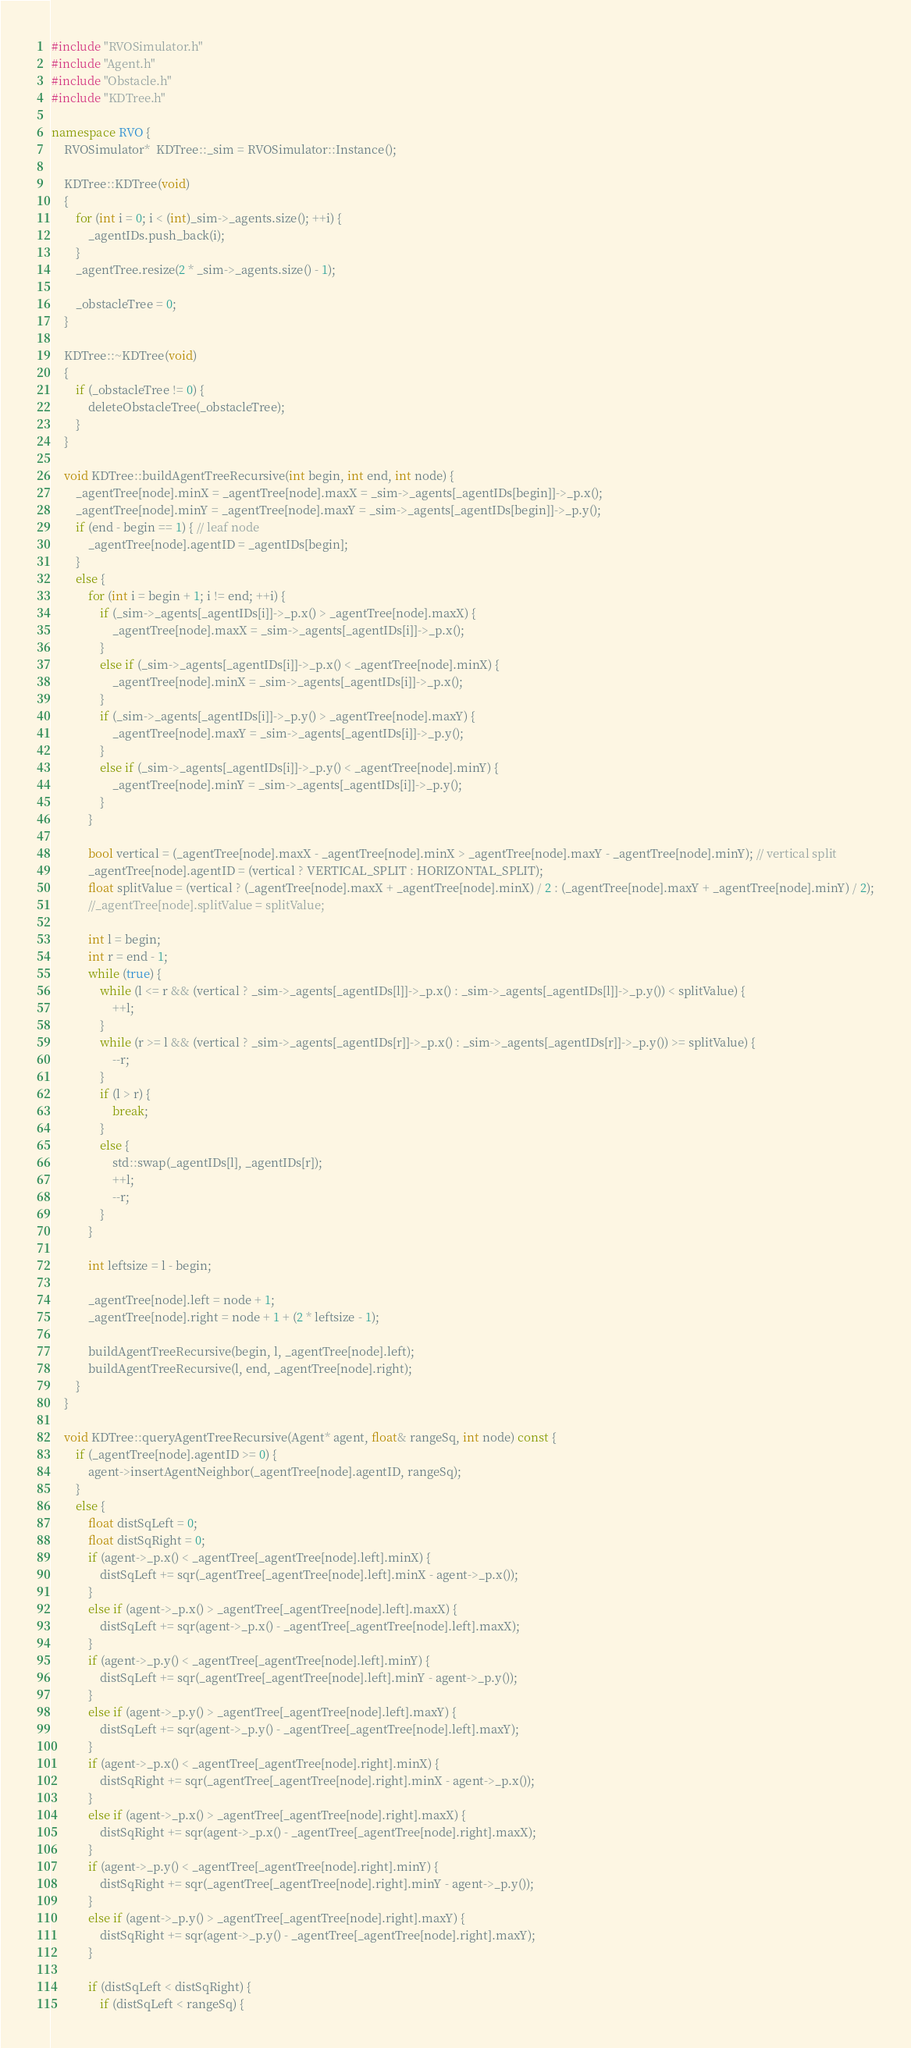Convert code to text. <code><loc_0><loc_0><loc_500><loc_500><_C++_>#include "RVOSimulator.h"
#include "Agent.h"
#include "Obstacle.h"
#include "KDTree.h"

namespace RVO {
	RVOSimulator*  KDTree::_sim = RVOSimulator::Instance();

	KDTree::KDTree(void)
	{
		for (int i = 0; i < (int)_sim->_agents.size(); ++i) {
			_agentIDs.push_back(i);
		}
		_agentTree.resize(2 * _sim->_agents.size() - 1);

		_obstacleTree = 0;
	}

	KDTree::~KDTree(void)
	{
		if (_obstacleTree != 0) {
			deleteObstacleTree(_obstacleTree);
		}
	}

	void KDTree::buildAgentTreeRecursive(int begin, int end, int node) {
		_agentTree[node].minX = _agentTree[node].maxX = _sim->_agents[_agentIDs[begin]]->_p.x();
		_agentTree[node].minY = _agentTree[node].maxY = _sim->_agents[_agentIDs[begin]]->_p.y();
		if (end - begin == 1) { // leaf node
			_agentTree[node].agentID = _agentIDs[begin];
		}
		else {
			for (int i = begin + 1; i != end; ++i) {
				if (_sim->_agents[_agentIDs[i]]->_p.x() > _agentTree[node].maxX) {
					_agentTree[node].maxX = _sim->_agents[_agentIDs[i]]->_p.x();
				}
				else if (_sim->_agents[_agentIDs[i]]->_p.x() < _agentTree[node].minX) {
					_agentTree[node].minX = _sim->_agents[_agentIDs[i]]->_p.x();
				}
				if (_sim->_agents[_agentIDs[i]]->_p.y() > _agentTree[node].maxY) {
					_agentTree[node].maxY = _sim->_agents[_agentIDs[i]]->_p.y();
				}
				else if (_sim->_agents[_agentIDs[i]]->_p.y() < _agentTree[node].minY) {
					_agentTree[node].minY = _sim->_agents[_agentIDs[i]]->_p.y();
				}
			}

			bool vertical = (_agentTree[node].maxX - _agentTree[node].minX > _agentTree[node].maxY - _agentTree[node].minY); // vertical split
			_agentTree[node].agentID = (vertical ? VERTICAL_SPLIT : HORIZONTAL_SPLIT);
			float splitValue = (vertical ? (_agentTree[node].maxX + _agentTree[node].minX) / 2 : (_agentTree[node].maxY + _agentTree[node].minY) / 2);
			//_agentTree[node].splitValue = splitValue;

			int l = begin;
			int r = end - 1;
			while (true) {
				while (l <= r && (vertical ? _sim->_agents[_agentIDs[l]]->_p.x() : _sim->_agents[_agentIDs[l]]->_p.y()) < splitValue) {
					++l;
				}
				while (r >= l && (vertical ? _sim->_agents[_agentIDs[r]]->_p.x() : _sim->_agents[_agentIDs[r]]->_p.y()) >= splitValue) {
					--r;
				}
				if (l > r) {
					break;
				}
				else {
					std::swap(_agentIDs[l], _agentIDs[r]);
					++l;
					--r;
				}
			}

			int leftsize = l - begin;

			_agentTree[node].left = node + 1;
			_agentTree[node].right = node + 1 + (2 * leftsize - 1);

			buildAgentTreeRecursive(begin, l, _agentTree[node].left);
			buildAgentTreeRecursive(l, end, _agentTree[node].right);
		}
	}

	void KDTree::queryAgentTreeRecursive(Agent* agent, float& rangeSq, int node) const {
		if (_agentTree[node].agentID >= 0) {
			agent->insertAgentNeighbor(_agentTree[node].agentID, rangeSq);
		}
		else {
			float distSqLeft = 0;
			float distSqRight = 0;
			if (agent->_p.x() < _agentTree[_agentTree[node].left].minX) {
				distSqLeft += sqr(_agentTree[_agentTree[node].left].minX - agent->_p.x());
			}
			else if (agent->_p.x() > _agentTree[_agentTree[node].left].maxX) {
				distSqLeft += sqr(agent->_p.x() - _agentTree[_agentTree[node].left].maxX);
			}
			if (agent->_p.y() < _agentTree[_agentTree[node].left].minY) {
				distSqLeft += sqr(_agentTree[_agentTree[node].left].minY - agent->_p.y());
			}
			else if (agent->_p.y() > _agentTree[_agentTree[node].left].maxY) {
				distSqLeft += sqr(agent->_p.y() - _agentTree[_agentTree[node].left].maxY);
			}
			if (agent->_p.x() < _agentTree[_agentTree[node].right].minX) {
				distSqRight += sqr(_agentTree[_agentTree[node].right].minX - agent->_p.x());
			}
			else if (agent->_p.x() > _agentTree[_agentTree[node].right].maxX) {
				distSqRight += sqr(agent->_p.x() - _agentTree[_agentTree[node].right].maxX);
			}
			if (agent->_p.y() < _agentTree[_agentTree[node].right].minY) {
				distSqRight += sqr(_agentTree[_agentTree[node].right].minY - agent->_p.y());
			}
			else if (agent->_p.y() > _agentTree[_agentTree[node].right].maxY) {
				distSqRight += sqr(agent->_p.y() - _agentTree[_agentTree[node].right].maxY);
			}

			if (distSqLeft < distSqRight) {
				if (distSqLeft < rangeSq) {</code> 